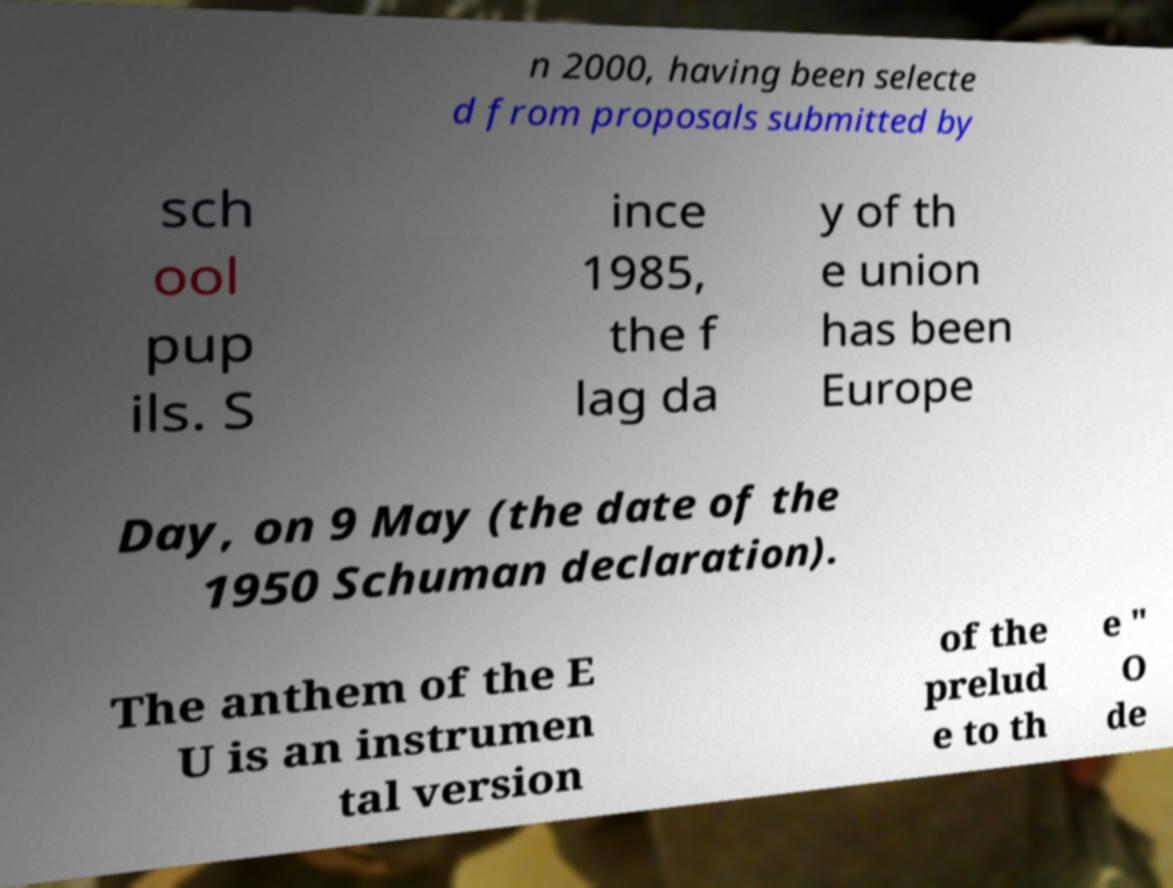Please read and relay the text visible in this image. What does it say? n 2000, having been selecte d from proposals submitted by sch ool pup ils. S ince 1985, the f lag da y of th e union has been Europe Day, on 9 May (the date of the 1950 Schuman declaration). The anthem of the E U is an instrumen tal version of the prelud e to th e " O de 